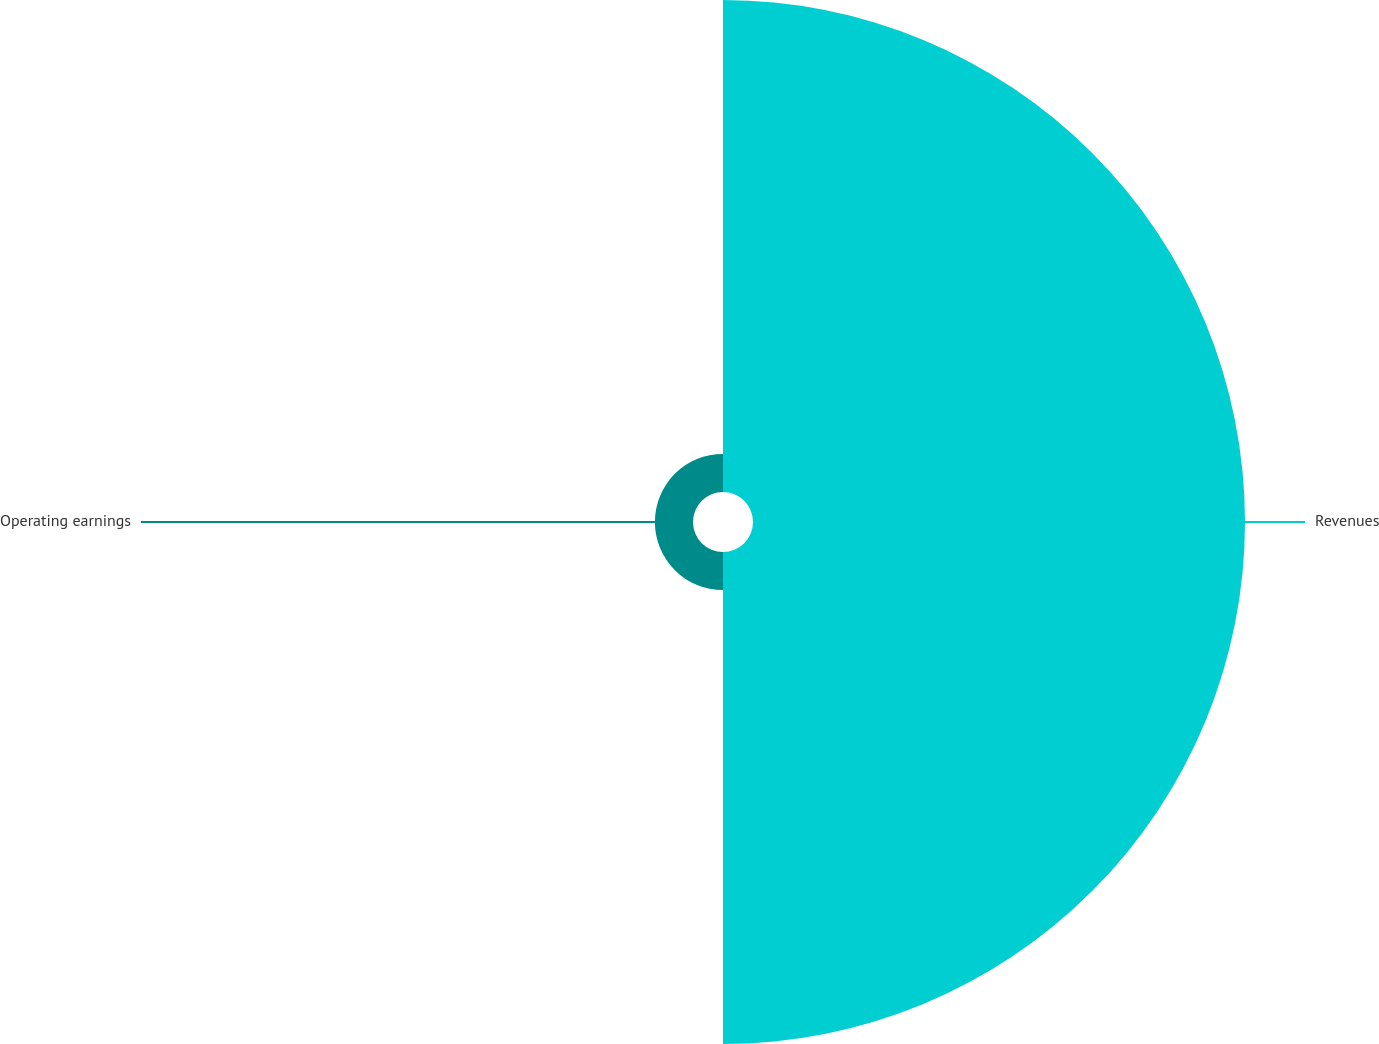<chart> <loc_0><loc_0><loc_500><loc_500><pie_chart><fcel>Revenues<fcel>Operating earnings<nl><fcel>92.81%<fcel>7.19%<nl></chart> 